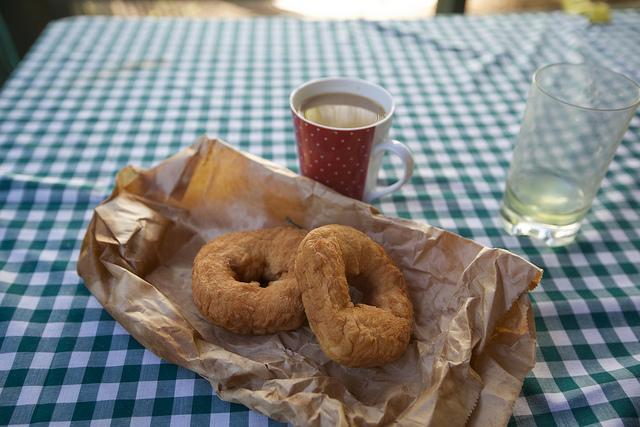What type of donuts are these? Please explain your reasoning. plain cake. These are just plain donuts. 